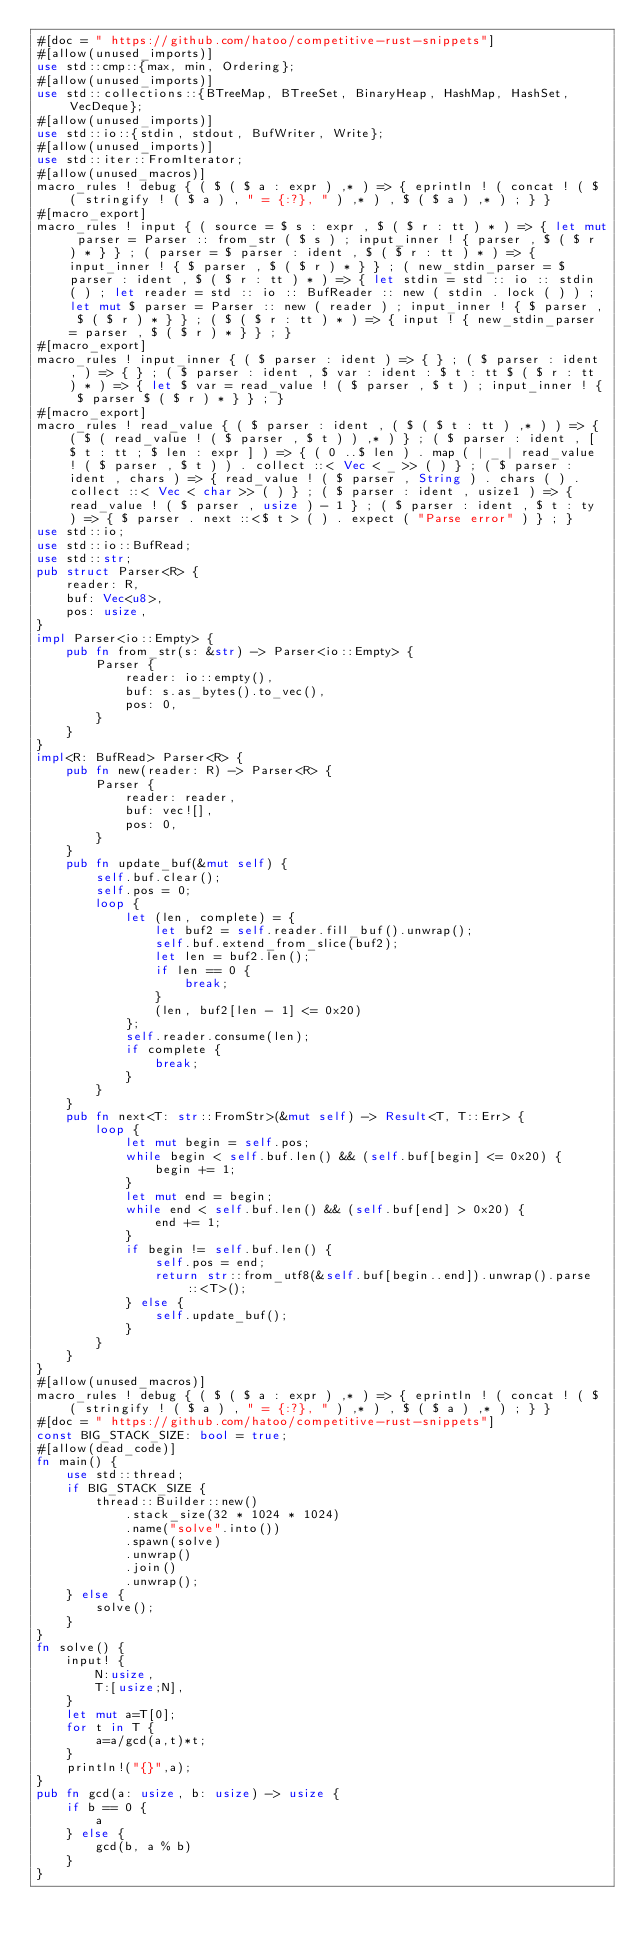<code> <loc_0><loc_0><loc_500><loc_500><_Rust_>#[doc = " https://github.com/hatoo/competitive-rust-snippets"]
#[allow(unused_imports)]
use std::cmp::{max, min, Ordering};
#[allow(unused_imports)]
use std::collections::{BTreeMap, BTreeSet, BinaryHeap, HashMap, HashSet, VecDeque};
#[allow(unused_imports)]
use std::io::{stdin, stdout, BufWriter, Write};
#[allow(unused_imports)]
use std::iter::FromIterator;
#[allow(unused_macros)]
macro_rules ! debug { ( $ ( $ a : expr ) ,* ) => { eprintln ! ( concat ! ( $ ( stringify ! ( $ a ) , " = {:?}, " ) ,* ) , $ ( $ a ) ,* ) ; } }
#[macro_export]
macro_rules ! input { ( source = $ s : expr , $ ( $ r : tt ) * ) => { let mut parser = Parser :: from_str ( $ s ) ; input_inner ! { parser , $ ( $ r ) * } } ; ( parser = $ parser : ident , $ ( $ r : tt ) * ) => { input_inner ! { $ parser , $ ( $ r ) * } } ; ( new_stdin_parser = $ parser : ident , $ ( $ r : tt ) * ) => { let stdin = std :: io :: stdin ( ) ; let reader = std :: io :: BufReader :: new ( stdin . lock ( ) ) ; let mut $ parser = Parser :: new ( reader ) ; input_inner ! { $ parser , $ ( $ r ) * } } ; ( $ ( $ r : tt ) * ) => { input ! { new_stdin_parser = parser , $ ( $ r ) * } } ; }
#[macro_export]
macro_rules ! input_inner { ( $ parser : ident ) => { } ; ( $ parser : ident , ) => { } ; ( $ parser : ident , $ var : ident : $ t : tt $ ( $ r : tt ) * ) => { let $ var = read_value ! ( $ parser , $ t ) ; input_inner ! { $ parser $ ( $ r ) * } } ; }
#[macro_export]
macro_rules ! read_value { ( $ parser : ident , ( $ ( $ t : tt ) ,* ) ) => { ( $ ( read_value ! ( $ parser , $ t ) ) ,* ) } ; ( $ parser : ident , [ $ t : tt ; $ len : expr ] ) => { ( 0 ..$ len ) . map ( | _ | read_value ! ( $ parser , $ t ) ) . collect ::< Vec < _ >> ( ) } ; ( $ parser : ident , chars ) => { read_value ! ( $ parser , String ) . chars ( ) . collect ::< Vec < char >> ( ) } ; ( $ parser : ident , usize1 ) => { read_value ! ( $ parser , usize ) - 1 } ; ( $ parser : ident , $ t : ty ) => { $ parser . next ::<$ t > ( ) . expect ( "Parse error" ) } ; }
use std::io;
use std::io::BufRead;
use std::str;
pub struct Parser<R> {
    reader: R,
    buf: Vec<u8>,
    pos: usize,
}
impl Parser<io::Empty> {
    pub fn from_str(s: &str) -> Parser<io::Empty> {
        Parser {
            reader: io::empty(),
            buf: s.as_bytes().to_vec(),
            pos: 0,
        }
    }
}
impl<R: BufRead> Parser<R> {
    pub fn new(reader: R) -> Parser<R> {
        Parser {
            reader: reader,
            buf: vec![],
            pos: 0,
        }
    }
    pub fn update_buf(&mut self) {
        self.buf.clear();
        self.pos = 0;
        loop {
            let (len, complete) = {
                let buf2 = self.reader.fill_buf().unwrap();
                self.buf.extend_from_slice(buf2);
                let len = buf2.len();
                if len == 0 {
                    break;
                }
                (len, buf2[len - 1] <= 0x20)
            };
            self.reader.consume(len);
            if complete {
                break;
            }
        }
    }
    pub fn next<T: str::FromStr>(&mut self) -> Result<T, T::Err> {
        loop {
            let mut begin = self.pos;
            while begin < self.buf.len() && (self.buf[begin] <= 0x20) {
                begin += 1;
            }
            let mut end = begin;
            while end < self.buf.len() && (self.buf[end] > 0x20) {
                end += 1;
            }
            if begin != self.buf.len() {
                self.pos = end;
                return str::from_utf8(&self.buf[begin..end]).unwrap().parse::<T>();
            } else {
                self.update_buf();
            }
        }
    }
}
#[allow(unused_macros)]
macro_rules ! debug { ( $ ( $ a : expr ) ,* ) => { eprintln ! ( concat ! ( $ ( stringify ! ( $ a ) , " = {:?}, " ) ,* ) , $ ( $ a ) ,* ) ; } }
#[doc = " https://github.com/hatoo/competitive-rust-snippets"]
const BIG_STACK_SIZE: bool = true;
#[allow(dead_code)]
fn main() {
    use std::thread;
    if BIG_STACK_SIZE {
        thread::Builder::new()
            .stack_size(32 * 1024 * 1024)
            .name("solve".into())
            .spawn(solve)
            .unwrap()
            .join()
            .unwrap();
    } else {
        solve();
    }
}
fn solve() {
    input! {
        N:usize,
        T:[usize;N],
    }
    let mut a=T[0];
    for t in T {
        a=a/gcd(a,t)*t;
    }
    println!("{}",a);
}
pub fn gcd(a: usize, b: usize) -> usize {
    if b == 0 {
        a
    } else {
        gcd(b, a % b)
    }
}</code> 